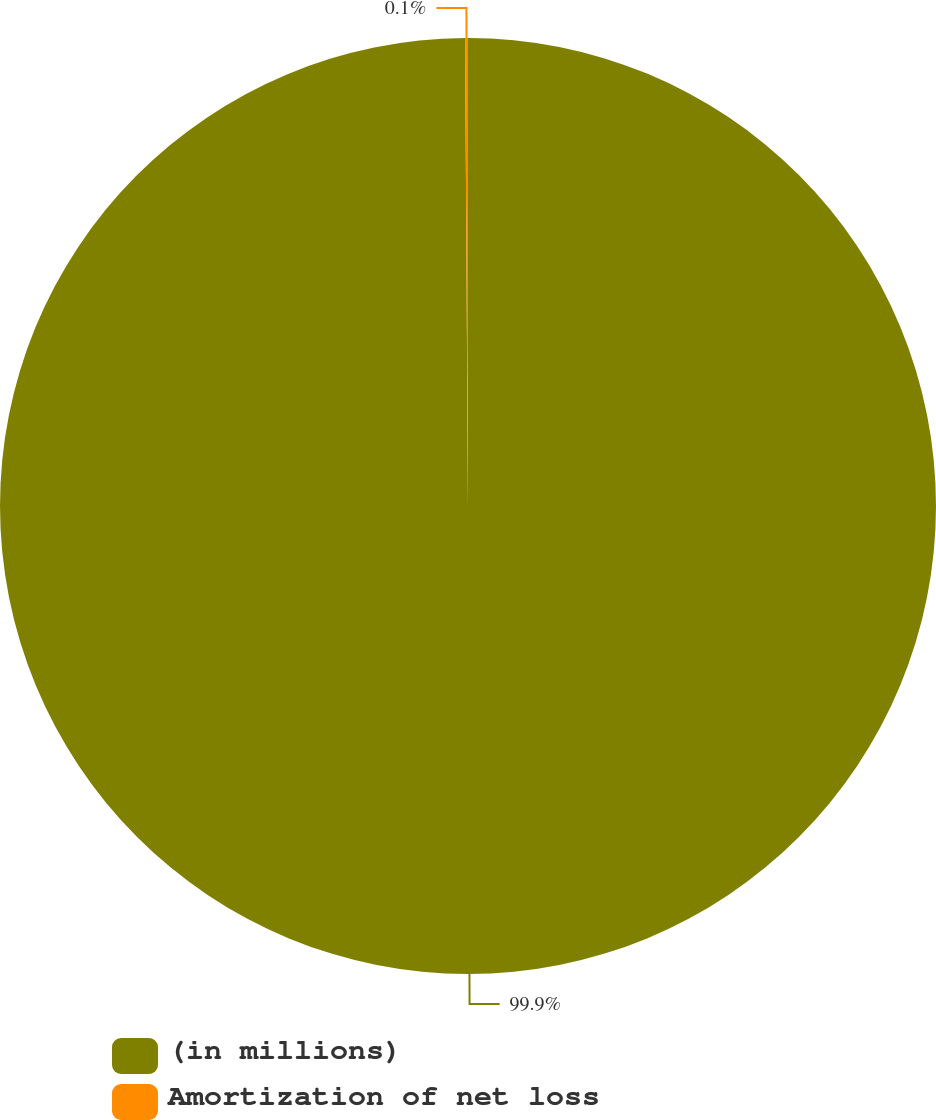Convert chart to OTSL. <chart><loc_0><loc_0><loc_500><loc_500><pie_chart><fcel>(in millions)<fcel>Amortization of net loss<nl><fcel>99.9%<fcel>0.1%<nl></chart> 